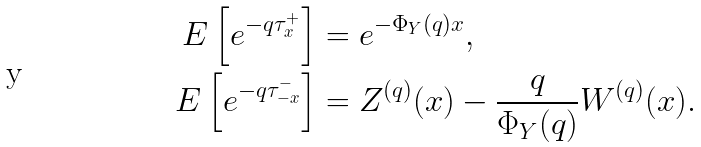Convert formula to latex. <formula><loc_0><loc_0><loc_500><loc_500>E \left [ e ^ { - q \tau ^ { + } _ { x } } \right ] & = e ^ { - \Phi _ { Y } ( q ) x } , \\ E \left [ e ^ { - q \tau ^ { - } _ { - x } } \right ] & = Z ^ { ( q ) } ( x ) - \frac { q } { \Phi _ { Y } ( q ) } W ^ { ( q ) } ( x ) .</formula> 